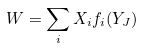Convert formula to latex. <formula><loc_0><loc_0><loc_500><loc_500>W = \sum _ { i } X _ { i } f _ { i } ( Y _ { J } )</formula> 